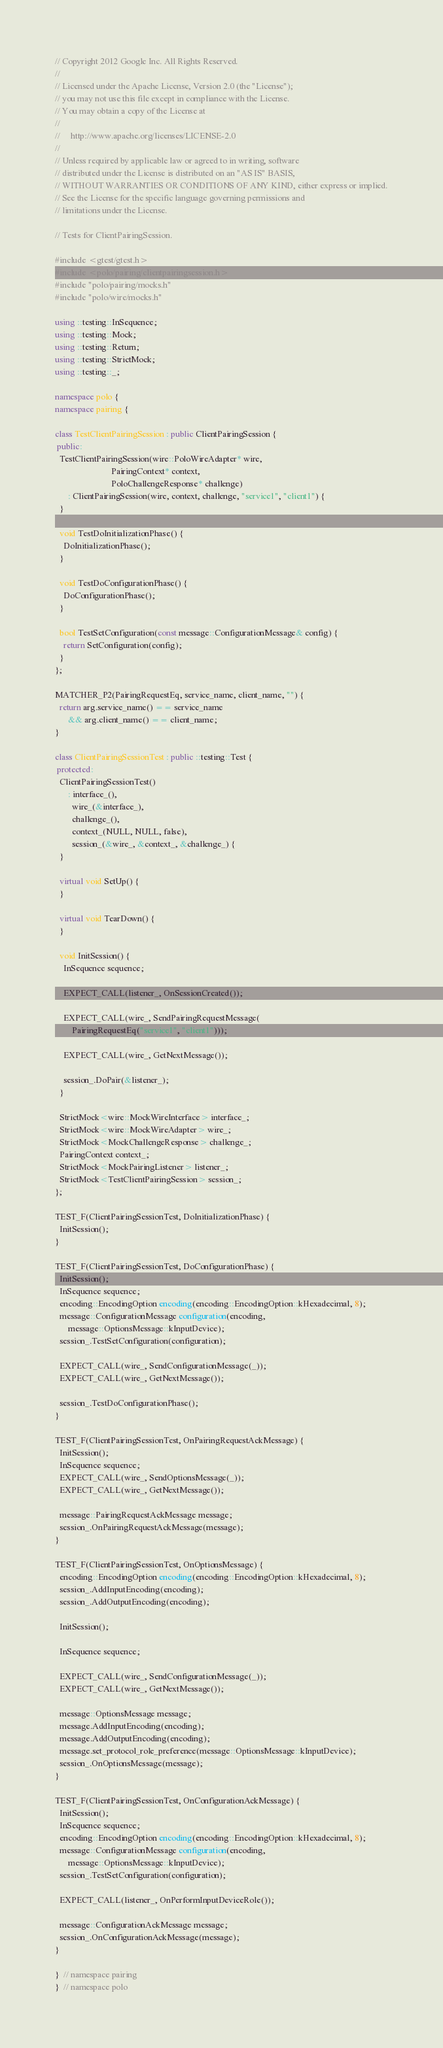<code> <loc_0><loc_0><loc_500><loc_500><_C++_>// Copyright 2012 Google Inc. All Rights Reserved.
//
// Licensed under the Apache License, Version 2.0 (the "License");
// you may not use this file except in compliance with the License.
// You may obtain a copy of the License at
//
//     http://www.apache.org/licenses/LICENSE-2.0
//
// Unless required by applicable law or agreed to in writing, software
// distributed under the License is distributed on an "AS IS" BASIS,
// WITHOUT WARRANTIES OR CONDITIONS OF ANY KIND, either express or implied.
// See the License for the specific language governing permissions and
// limitations under the License.

// Tests for ClientPairingSession.

#include <gtest/gtest.h>
#include <polo/pairing/clientpairingsession.h>
#include "polo/pairing/mocks.h"
#include "polo/wire/mocks.h"

using ::testing::InSequence;
using ::testing::Mock;
using ::testing::Return;
using ::testing::StrictMock;
using ::testing::_;

namespace polo {
namespace pairing {

class TestClientPairingSession : public ClientPairingSession {
 public:
  TestClientPairingSession(wire::PoloWireAdapter* wire,
                          PairingContext* context,
                          PoloChallengeResponse* challenge)
      : ClientPairingSession(wire, context, challenge, "service1", "client1") {
  }

  void TestDoInitializationPhase() {
    DoInitializationPhase();
  }

  void TestDoConfigurationPhase() {
    DoConfigurationPhase();
  }

  bool TestSetConfiguration(const message::ConfigurationMessage& config) {
    return SetConfiguration(config);
  }
};

MATCHER_P2(PairingRequestEq, service_name, client_name, "") {
  return arg.service_name() == service_name
      && arg.client_name() == client_name;
}

class ClientPairingSessionTest : public ::testing::Test {
 protected:
  ClientPairingSessionTest()
      : interface_(),
        wire_(&interface_),
        challenge_(),
        context_(NULL, NULL, false),
        session_(&wire_, &context_, &challenge_) {
  }

  virtual void SetUp() {
  }

  virtual void TearDown() {
  }

  void InitSession() {
    InSequence sequence;

    EXPECT_CALL(listener_, OnSessionCreated());

    EXPECT_CALL(wire_, SendPairingRequestMessage(
        PairingRequestEq("service1", "client1")));

    EXPECT_CALL(wire_, GetNextMessage());

    session_.DoPair(&listener_);
  }

  StrictMock<wire::MockWireInterface> interface_;
  StrictMock<wire::MockWireAdapter> wire_;
  StrictMock<MockChallengeResponse> challenge_;
  PairingContext context_;
  StrictMock<MockPairingListener> listener_;
  StrictMock<TestClientPairingSession> session_;
};

TEST_F(ClientPairingSessionTest, DoInitializationPhase) {
  InitSession();
}

TEST_F(ClientPairingSessionTest, DoConfigurationPhase) {
  InitSession();
  InSequence sequence;
  encoding::EncodingOption encoding(encoding::EncodingOption::kHexadecimal, 8);
  message::ConfigurationMessage configuration(encoding,
      message::OptionsMessage::kInputDevice);
  session_.TestSetConfiguration(configuration);

  EXPECT_CALL(wire_, SendConfigurationMessage(_));
  EXPECT_CALL(wire_, GetNextMessage());

  session_.TestDoConfigurationPhase();
}

TEST_F(ClientPairingSessionTest, OnPairingRequestAckMessage) {
  InitSession();
  InSequence sequence;
  EXPECT_CALL(wire_, SendOptionsMessage(_));
  EXPECT_CALL(wire_, GetNextMessage());

  message::PairingRequestAckMessage message;
  session_.OnPairingRequestAckMessage(message);
}

TEST_F(ClientPairingSessionTest, OnOptionsMessage) {
  encoding::EncodingOption encoding(encoding::EncodingOption::kHexadecimal, 8);
  session_.AddInputEncoding(encoding);
  session_.AddOutputEncoding(encoding);

  InitSession();

  InSequence sequence;

  EXPECT_CALL(wire_, SendConfigurationMessage(_));
  EXPECT_CALL(wire_, GetNextMessage());

  message::OptionsMessage message;
  message.AddInputEncoding(encoding);
  message.AddOutputEncoding(encoding);
  message.set_protocol_role_preference(message::OptionsMessage::kInputDevice);
  session_.OnOptionsMessage(message);
}

TEST_F(ClientPairingSessionTest, OnConfigurationAckMessage) {
  InitSession();
  InSequence sequence;
  encoding::EncodingOption encoding(encoding::EncodingOption::kHexadecimal, 8);
  message::ConfigurationMessage configuration(encoding,
      message::OptionsMessage::kInputDevice);
  session_.TestSetConfiguration(configuration);

  EXPECT_CALL(listener_, OnPerformInputDeviceRole());

  message::ConfigurationAckMessage message;
  session_.OnConfigurationAckMessage(message);
}

}  // namespace pairing
}  // namespace polo
</code> 